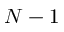Convert formula to latex. <formula><loc_0><loc_0><loc_500><loc_500>N - 1</formula> 